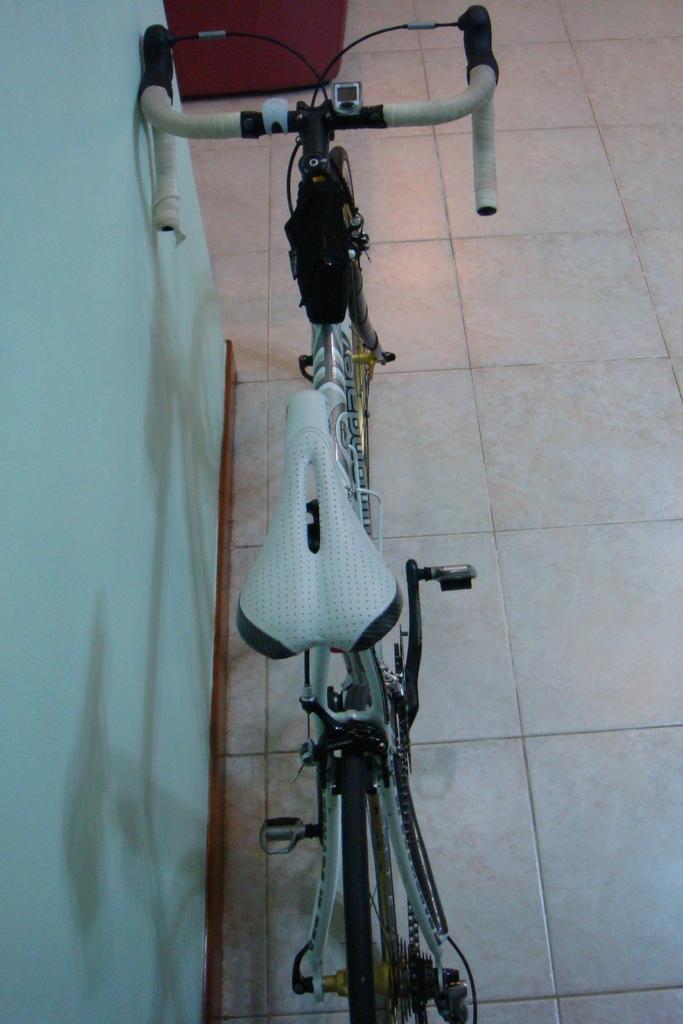Could you give a brief overview of what you see in this image? In this picture there is a bicycle. At the back there is an object on the left side of the image there is a wall and there is a shadow of the bicycle on the wall. At the bottom there are tiles 